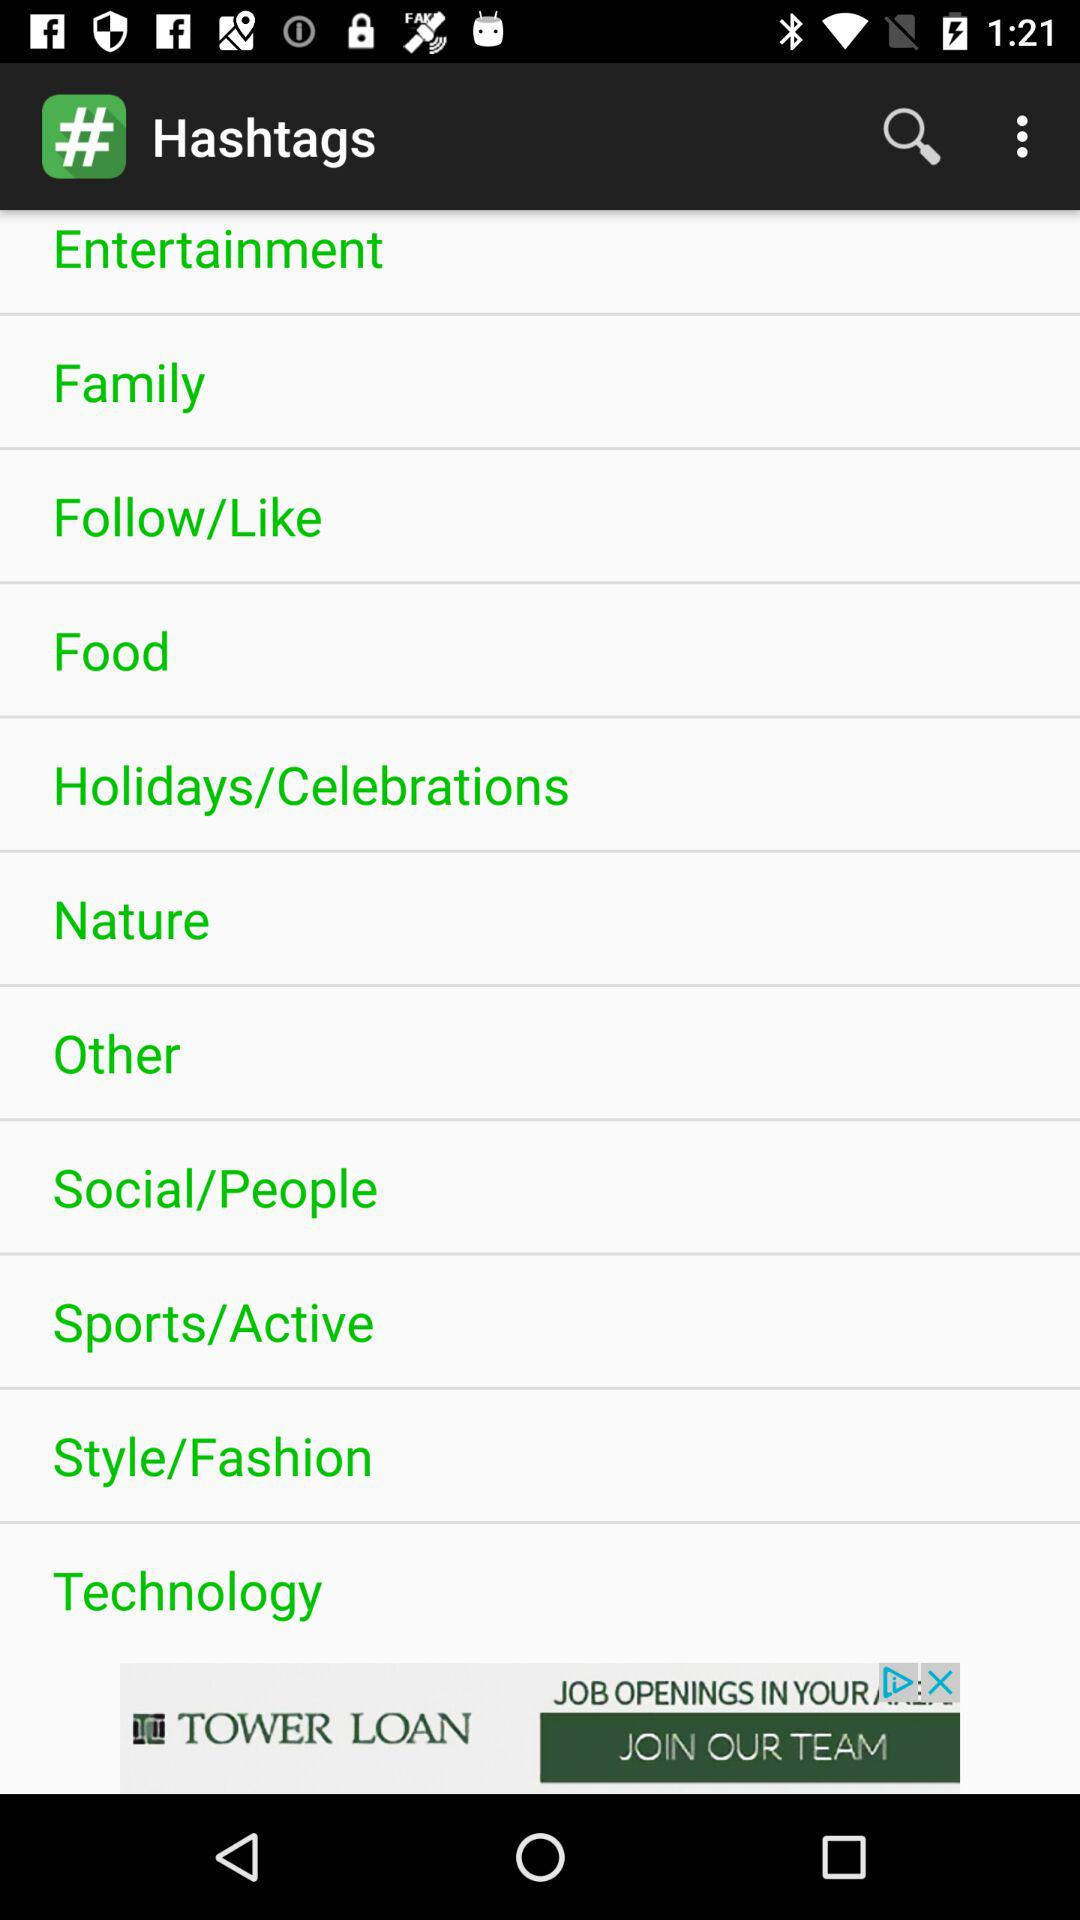What is the name of the application? The name of the application is "Hashtags". 